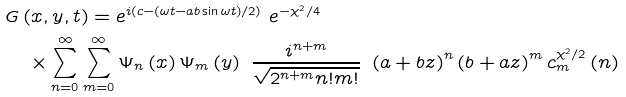<formula> <loc_0><loc_0><loc_500><loc_500>& G \left ( x , y , t \right ) = e ^ { i \left ( c - \left ( \omega t - a b \sin \omega t \right ) / 2 \right ) } \ e ^ { - \chi ^ { 2 } / 4 } \\ & \quad \times \sum _ { n = 0 } ^ { \infty } \sum _ { m = 0 } ^ { \infty } \Psi _ { n } \left ( x \right ) \Psi _ { m } \left ( y \right ) \ \frac { i ^ { n + m } } { \sqrt { 2 ^ { n + m } n ! m ! } } \ \left ( a + b z \right ) ^ { n } \left ( b + a z \right ) ^ { m } c _ { m } ^ { \chi ^ { 2 } / 2 } \left ( n \right )</formula> 